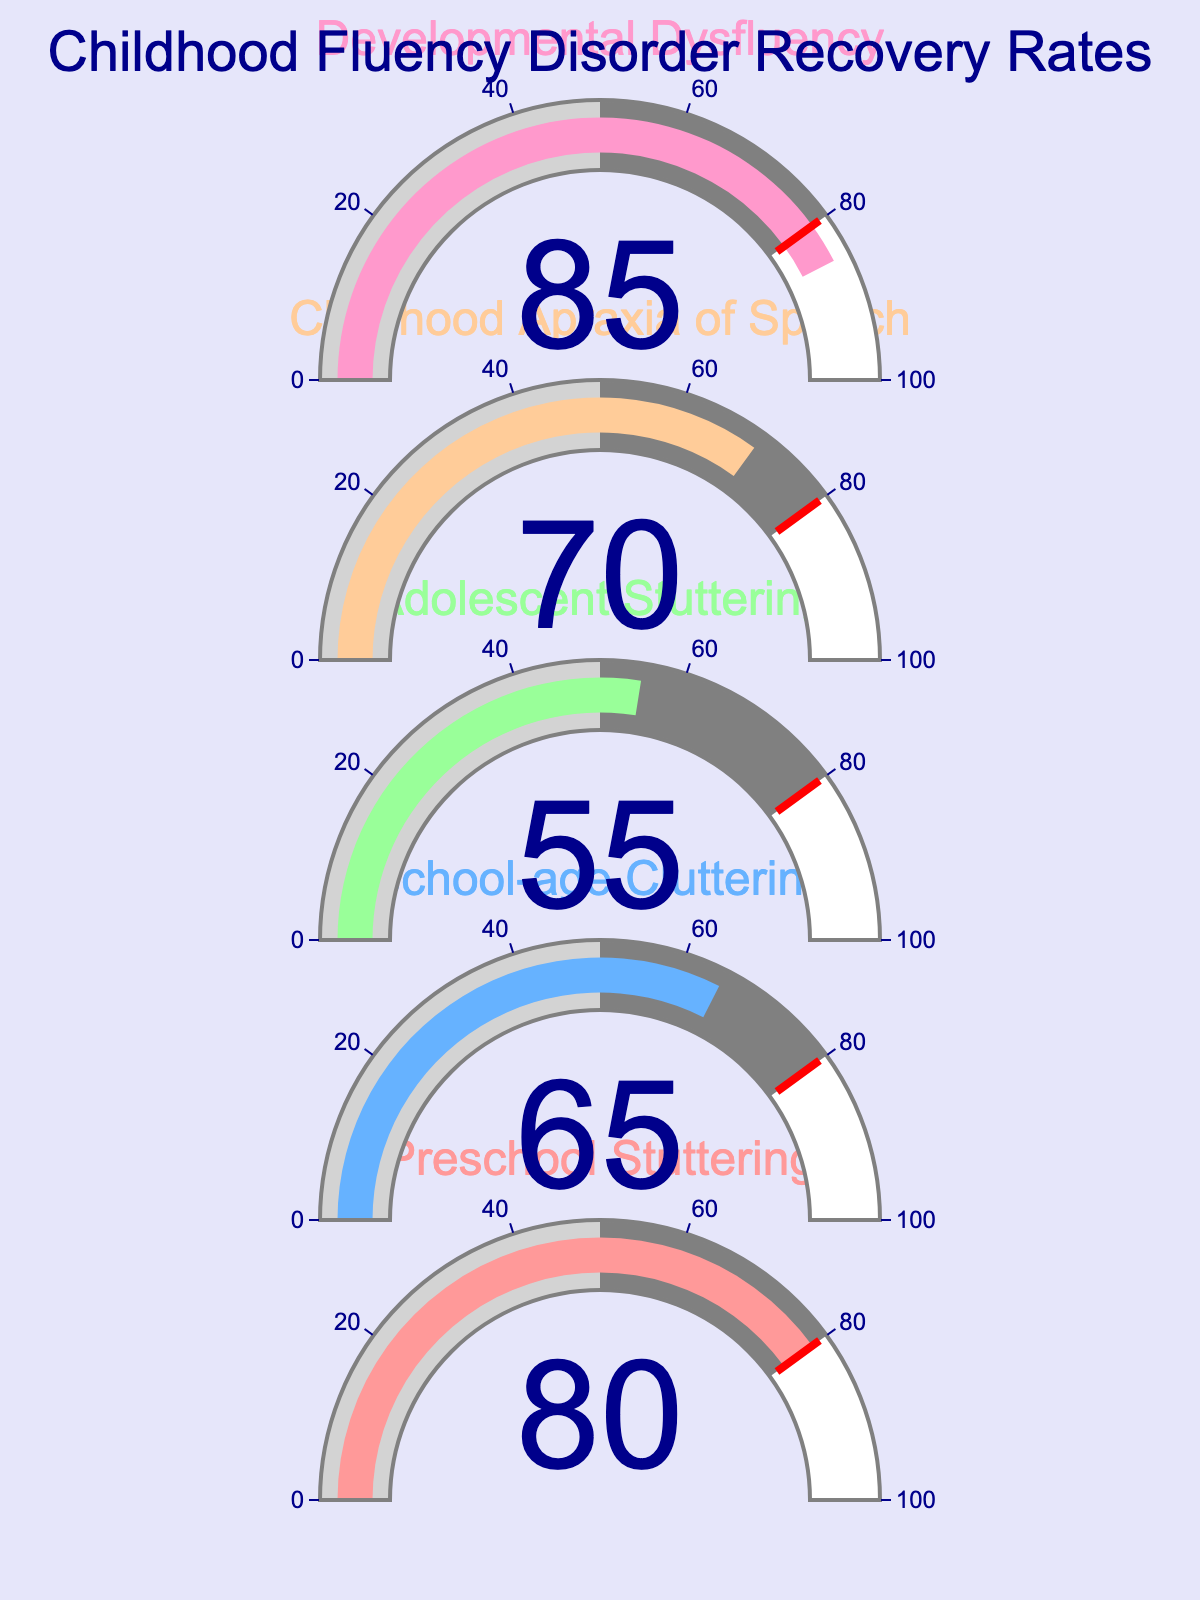What is the title of the figure? The title is usually located at the top of the figure. In this figure, it is mentioned that the title is at the top, indicating "Childhood Fluency Disorder Recovery Rates".
Answer: Childhood Fluency Disorder Recovery Rates What is the recovery rate for Preschool Stuttering? To find the recovery rate, look at the gauge chart for Preschool Stuttering. The value indicated on the gauge is the recovery rate.
Answer: 80 Which disorder has the highest recovery rate? Comparing all the gauges, the one with the highest value indicates the highest recovery rate. The Developmental Dysfluency gauge shows the highest value, 85.
Answer: Developmental Dysfluency What's the difference in recovery rates between Childhood Apraxia of Speech and Adolescent Stuttering? Subtract the recovery rate of Adolescent Stuttering from that of Childhood Apraxia of Speech. It is 70 - 55.
Answer: 15 What color is used for the Preschool Stuttering gauge? Identify the color associated with the Preschool Stuttering indicator. It is the first in the color list which is '#FF9999' or a shade of red.
Answer: Red Which disorders have recovery rates higher than 65? Examine each gauge showing a recovery rate higher than 65. They are Preschool Stuttering (80), Childhood Apraxia of Speech (70), and Developmental Dysfluency (85).
Answer: Preschool Stuttering, Childhood Apraxia of Speech, Developmental Dysfluency What is the average recovery rate across all disorders? Sum all the recovery rates and divide by the number of disorders. The calculation is (80+65+55+70+85)/5.
Answer: 71 Is the recovery rate for School-age Cluttering above or below the threshold of 80? Compare the recovery rate of School-age Cluttering which is 65 to the threshold value 80.
Answer: Below Which disorder has the lowest recovery rate? Find the gauge with the smallest value. Adolescent Stuttering has the lowest recovery rate at 55.
Answer: Adolescent Stuttering What's the range of recovery rates shown in the figure? Locate the minimum and maximum recovery rates from the gauges. The minimum is 55 and the maximum is 85, so the range is from 55 to 85.
Answer: 55 to 85 